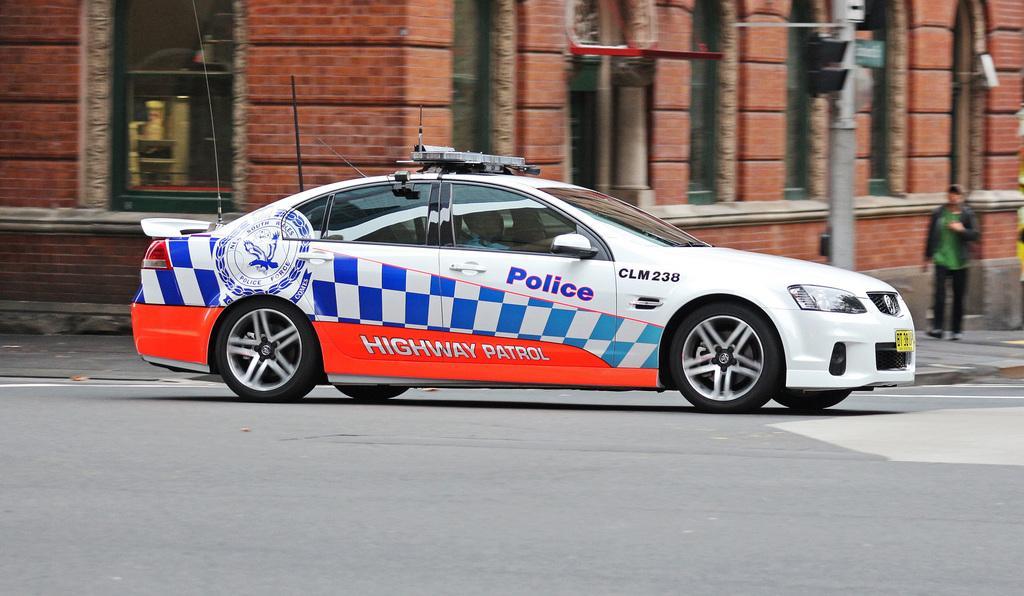Please provide a concise description of this image. In the foreground, I can see a car on the road and two persons. In the background, I can see buildings, light poles, windows and boards. This image taken, maybe during a day. 